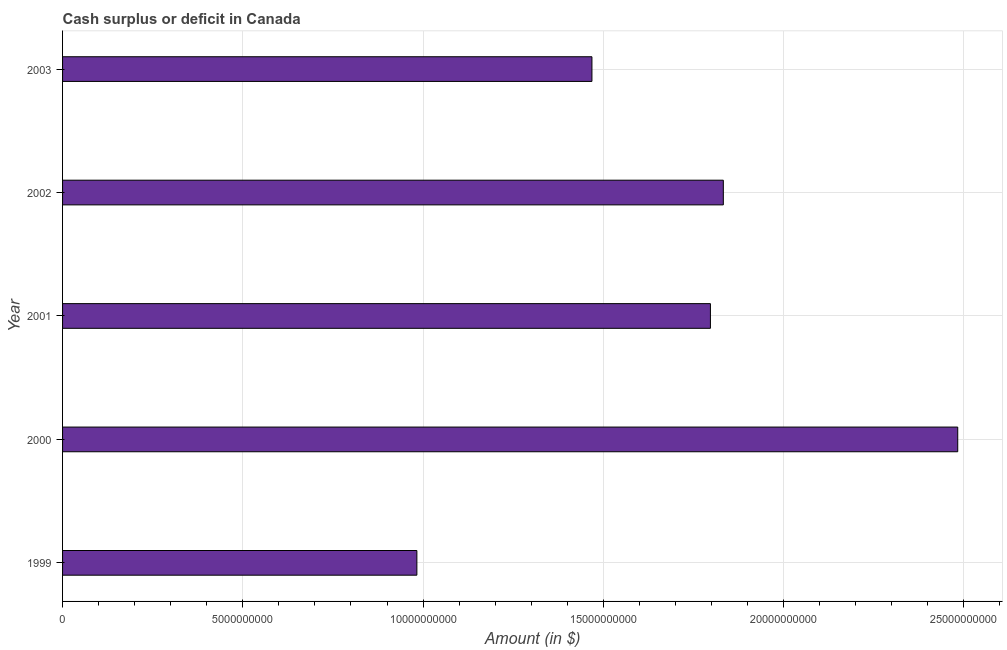What is the title of the graph?
Make the answer very short. Cash surplus or deficit in Canada. What is the label or title of the X-axis?
Your answer should be very brief. Amount (in $). What is the label or title of the Y-axis?
Keep it short and to the point. Year. What is the cash surplus or deficit in 2002?
Offer a very short reply. 1.83e+1. Across all years, what is the maximum cash surplus or deficit?
Offer a very short reply. 2.48e+1. Across all years, what is the minimum cash surplus or deficit?
Keep it short and to the point. 9.83e+09. What is the sum of the cash surplus or deficit?
Offer a terse response. 8.56e+1. What is the difference between the cash surplus or deficit in 1999 and 2000?
Offer a very short reply. -1.50e+1. What is the average cash surplus or deficit per year?
Offer a terse response. 1.71e+1. What is the median cash surplus or deficit?
Your answer should be compact. 1.80e+1. Do a majority of the years between 2003 and 2001 (inclusive) have cash surplus or deficit greater than 2000000000 $?
Keep it short and to the point. Yes. What is the ratio of the cash surplus or deficit in 2000 to that in 2003?
Your response must be concise. 1.69. Is the cash surplus or deficit in 2001 less than that in 2002?
Provide a succinct answer. Yes. What is the difference between the highest and the second highest cash surplus or deficit?
Your answer should be compact. 6.50e+09. Is the sum of the cash surplus or deficit in 1999 and 2001 greater than the maximum cash surplus or deficit across all years?
Your response must be concise. Yes. What is the difference between the highest and the lowest cash surplus or deficit?
Provide a short and direct response. 1.50e+1. How many years are there in the graph?
Your answer should be very brief. 5. What is the difference between two consecutive major ticks on the X-axis?
Provide a short and direct response. 5.00e+09. What is the Amount (in $) in 1999?
Give a very brief answer. 9.83e+09. What is the Amount (in $) in 2000?
Offer a very short reply. 2.48e+1. What is the Amount (in $) of 2001?
Your response must be concise. 1.80e+1. What is the Amount (in $) of 2002?
Offer a terse response. 1.83e+1. What is the Amount (in $) of 2003?
Offer a terse response. 1.47e+1. What is the difference between the Amount (in $) in 1999 and 2000?
Your answer should be very brief. -1.50e+1. What is the difference between the Amount (in $) in 1999 and 2001?
Make the answer very short. -8.14e+09. What is the difference between the Amount (in $) in 1999 and 2002?
Give a very brief answer. -8.50e+09. What is the difference between the Amount (in $) in 1999 and 2003?
Your answer should be compact. -4.86e+09. What is the difference between the Amount (in $) in 2000 and 2001?
Your answer should be very brief. 6.86e+09. What is the difference between the Amount (in $) in 2000 and 2002?
Provide a short and direct response. 6.50e+09. What is the difference between the Amount (in $) in 2000 and 2003?
Give a very brief answer. 1.01e+1. What is the difference between the Amount (in $) in 2001 and 2002?
Give a very brief answer. -3.58e+08. What is the difference between the Amount (in $) in 2001 and 2003?
Keep it short and to the point. 3.29e+09. What is the difference between the Amount (in $) in 2002 and 2003?
Make the answer very short. 3.64e+09. What is the ratio of the Amount (in $) in 1999 to that in 2000?
Offer a very short reply. 0.4. What is the ratio of the Amount (in $) in 1999 to that in 2001?
Your response must be concise. 0.55. What is the ratio of the Amount (in $) in 1999 to that in 2002?
Give a very brief answer. 0.54. What is the ratio of the Amount (in $) in 1999 to that in 2003?
Make the answer very short. 0.67. What is the ratio of the Amount (in $) in 2000 to that in 2001?
Your response must be concise. 1.38. What is the ratio of the Amount (in $) in 2000 to that in 2002?
Ensure brevity in your answer.  1.35. What is the ratio of the Amount (in $) in 2000 to that in 2003?
Keep it short and to the point. 1.69. What is the ratio of the Amount (in $) in 2001 to that in 2003?
Keep it short and to the point. 1.22. What is the ratio of the Amount (in $) in 2002 to that in 2003?
Provide a short and direct response. 1.25. 